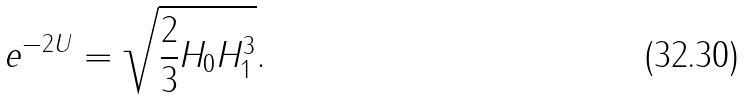<formula> <loc_0><loc_0><loc_500><loc_500>e ^ { - 2 U } & = \sqrt { \frac { 2 } { 3 } H _ { 0 } H _ { 1 } ^ { 3 } } .</formula> 